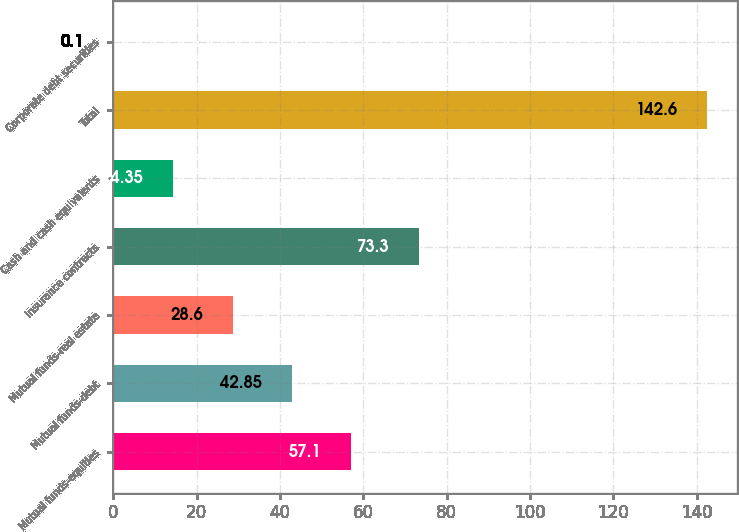Convert chart. <chart><loc_0><loc_0><loc_500><loc_500><bar_chart><fcel>Mutual funds-equities<fcel>Mutual funds-debt<fcel>Mutual funds-real estate<fcel>Insurance contracts<fcel>Cash and cash equivalents<fcel>Total<fcel>Corporate debt securities<nl><fcel>57.1<fcel>42.85<fcel>28.6<fcel>73.3<fcel>14.35<fcel>142.6<fcel>0.1<nl></chart> 